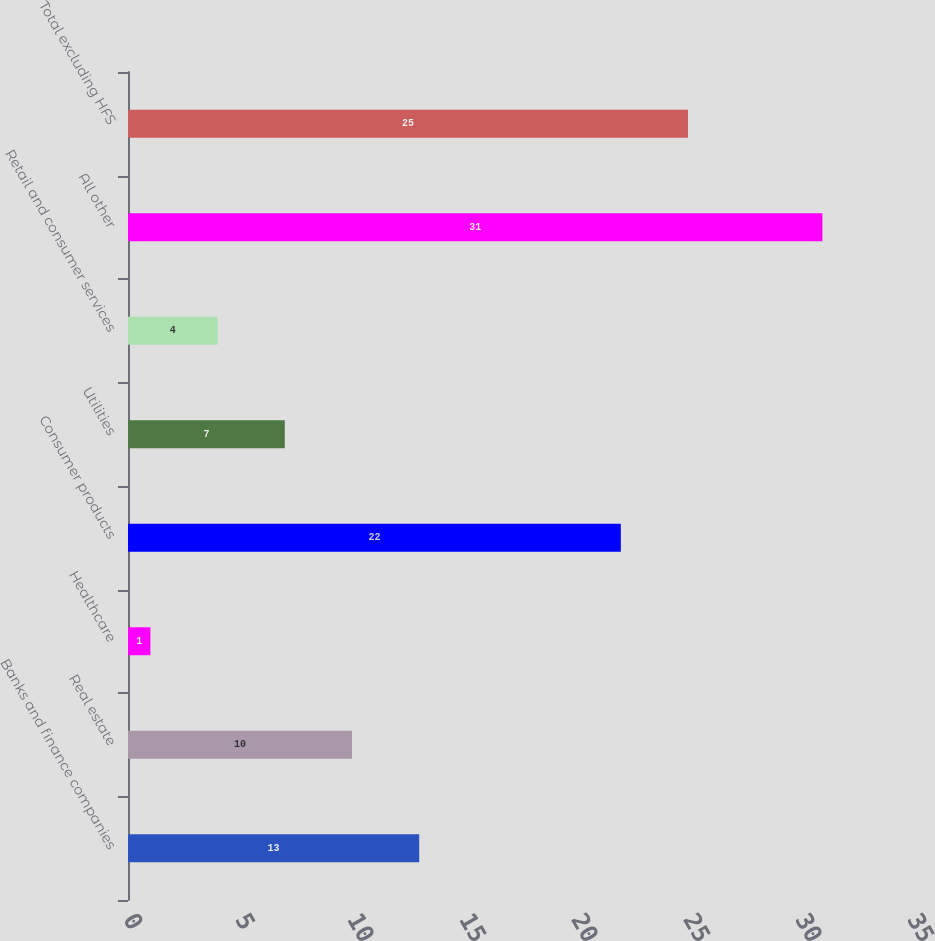<chart> <loc_0><loc_0><loc_500><loc_500><bar_chart><fcel>Banks and finance companies<fcel>Real estate<fcel>Healthcare<fcel>Consumer products<fcel>Utilities<fcel>Retail and consumer services<fcel>All other<fcel>Total excluding HFS<nl><fcel>13<fcel>10<fcel>1<fcel>22<fcel>7<fcel>4<fcel>31<fcel>25<nl></chart> 